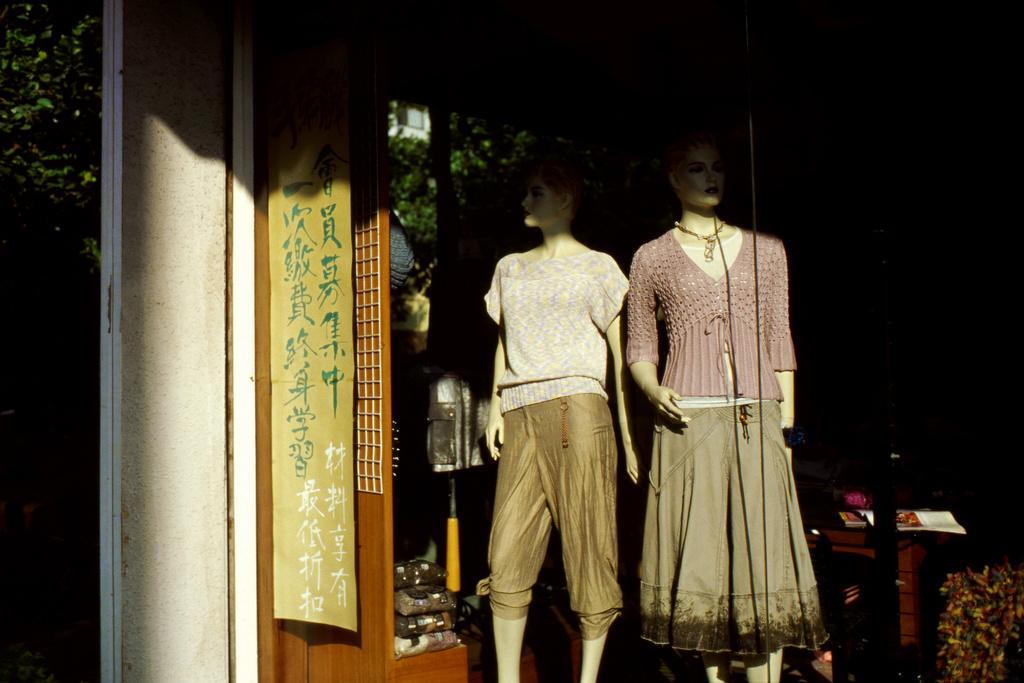Can you describe this image briefly? In this image I can see two mannequins in the center of the image, a pole or a pillar, some other objects, trees and plants behind. I can see a banner hanging with some text. 